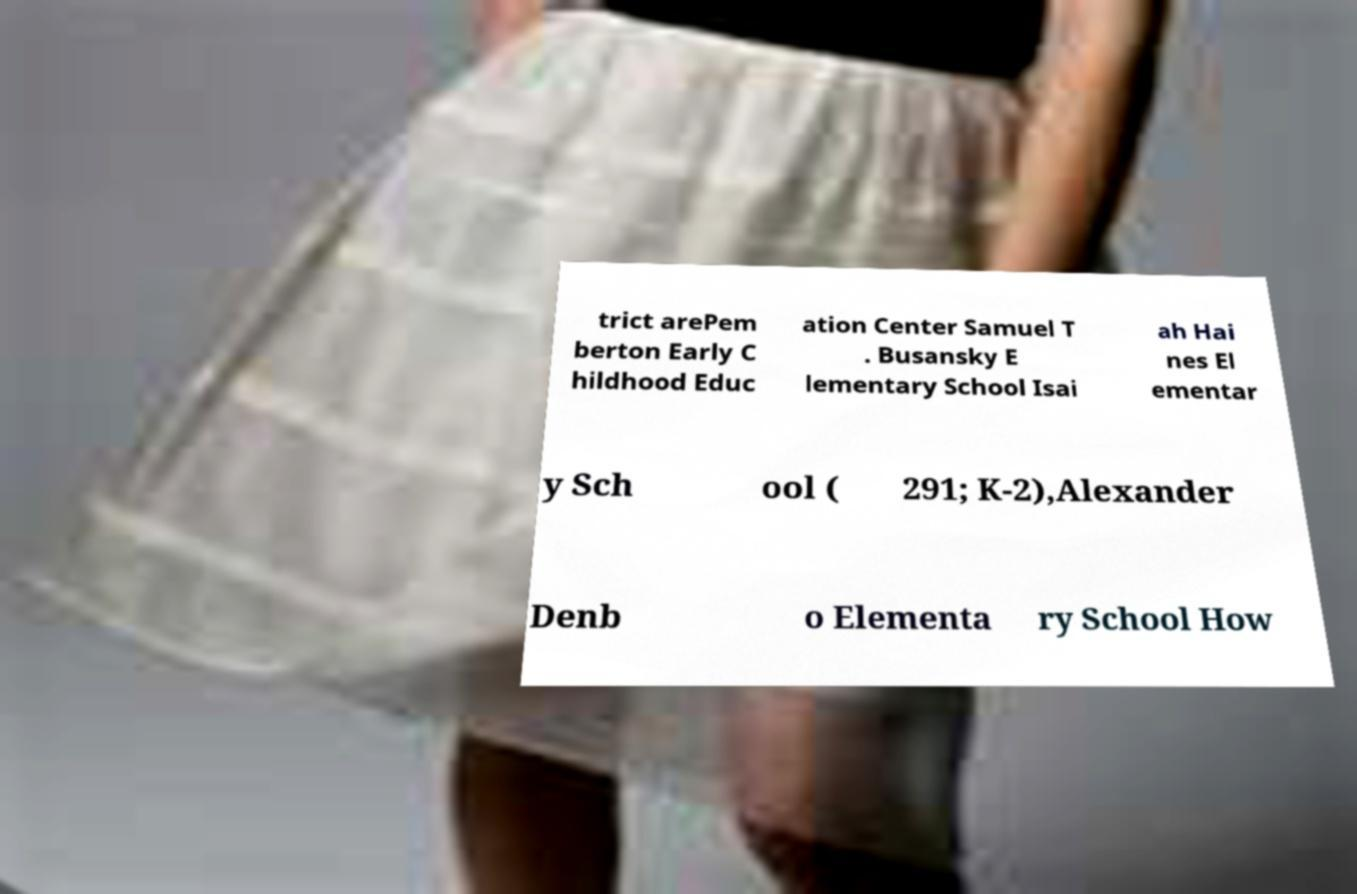Please identify and transcribe the text found in this image. trict arePem berton Early C hildhood Educ ation Center Samuel T . Busansky E lementary School Isai ah Hai nes El ementar y Sch ool ( 291; K-2),Alexander Denb o Elementa ry School How 